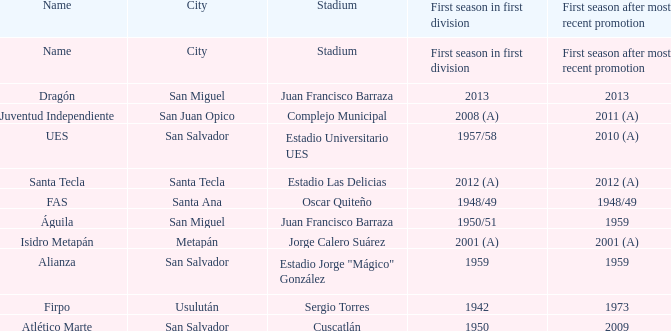Which city is Alianza? San Salvador. 